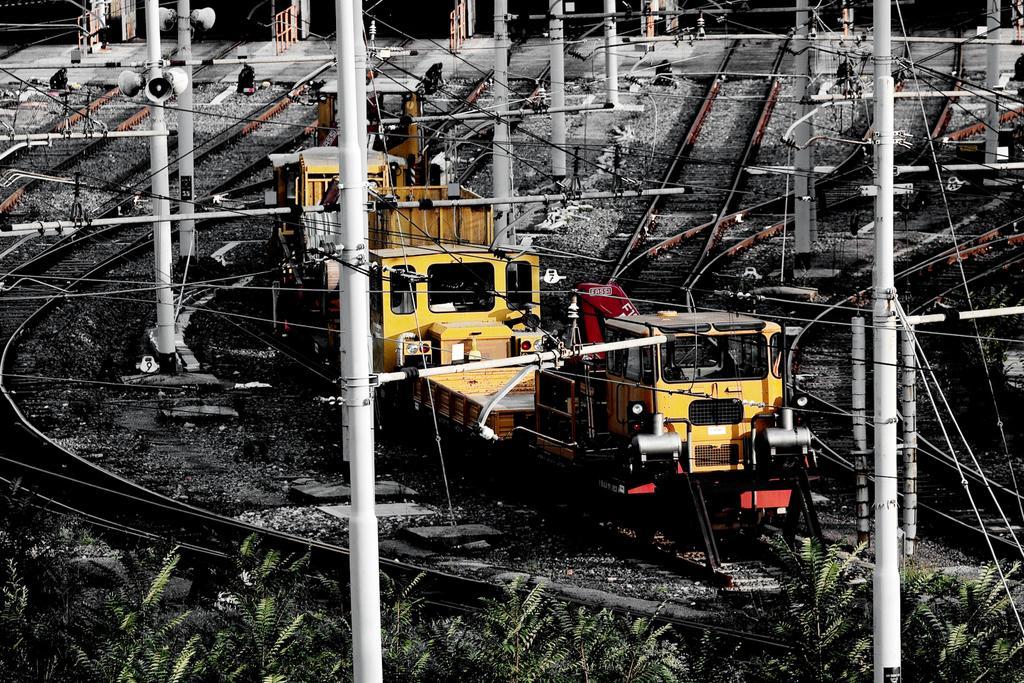Describe this image in one or two sentences. In the picture I can see a train on a railway track. The train is yellow in color. In the background I can see poles which has wires attached to them, railway tracks, plants and some other objects. 